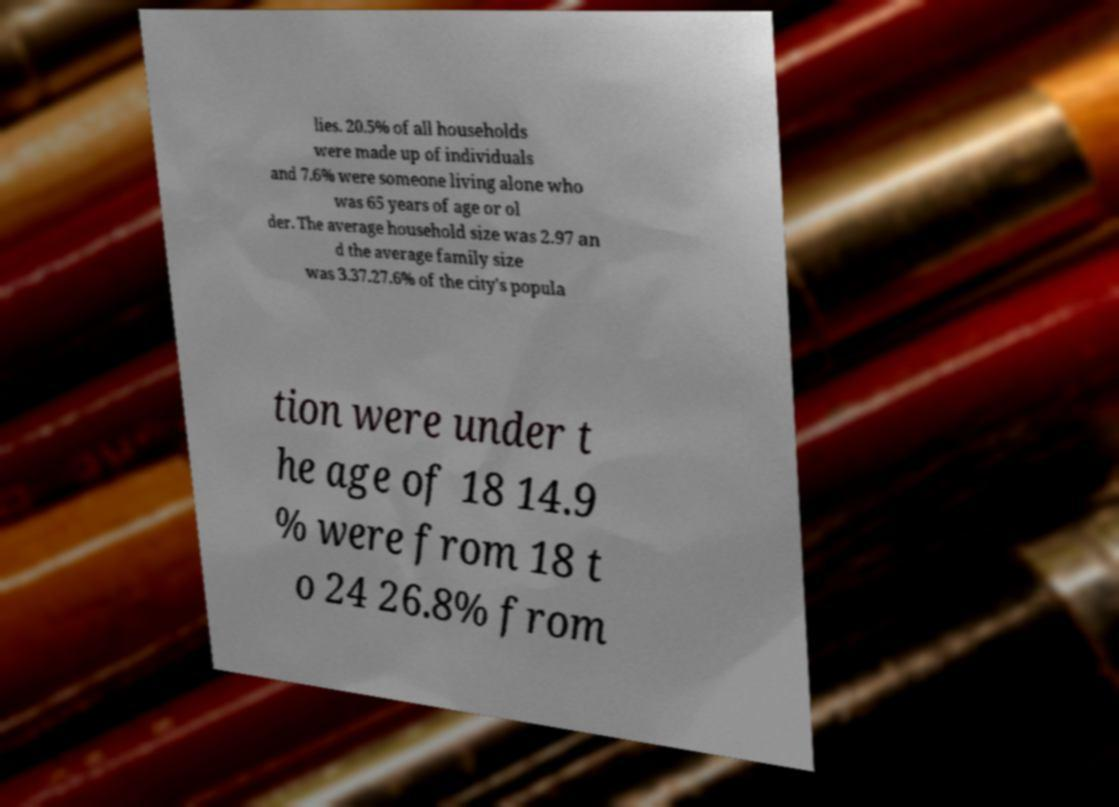What messages or text are displayed in this image? I need them in a readable, typed format. lies. 20.5% of all households were made up of individuals and 7.6% were someone living alone who was 65 years of age or ol der. The average household size was 2.97 an d the average family size was 3.37.27.6% of the city's popula tion were under t he age of 18 14.9 % were from 18 t o 24 26.8% from 